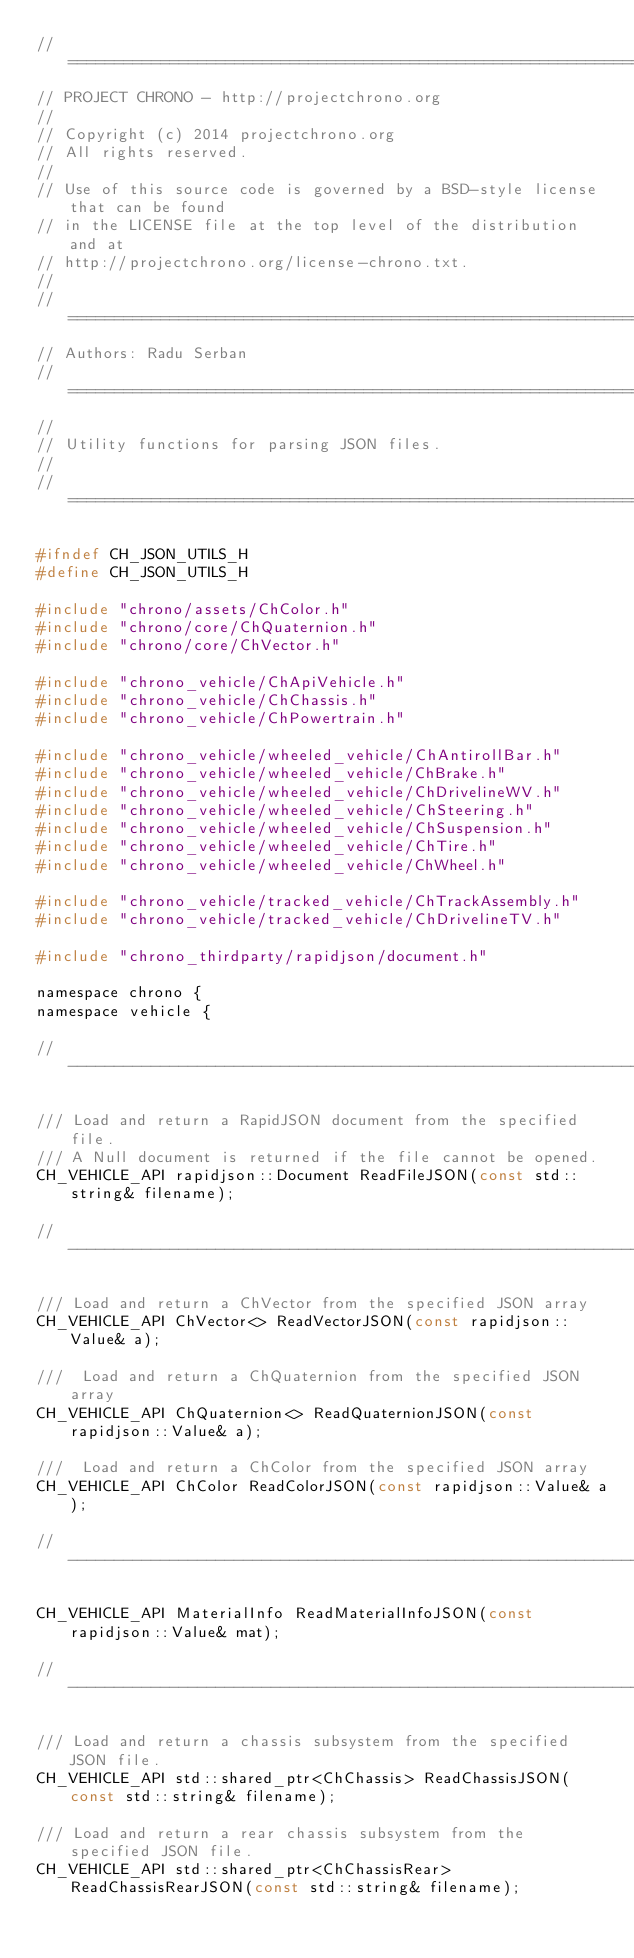<code> <loc_0><loc_0><loc_500><loc_500><_C_>// =============================================================================
// PROJECT CHRONO - http://projectchrono.org
//
// Copyright (c) 2014 projectchrono.org
// All rights reserved.
//
// Use of this source code is governed by a BSD-style license that can be found
// in the LICENSE file at the top level of the distribution and at
// http://projectchrono.org/license-chrono.txt.
//
// =============================================================================
// Authors: Radu Serban
// =============================================================================
//
// Utility functions for parsing JSON files.
//
// =============================================================================

#ifndef CH_JSON_UTILS_H
#define CH_JSON_UTILS_H

#include "chrono/assets/ChColor.h"
#include "chrono/core/ChQuaternion.h"
#include "chrono/core/ChVector.h"

#include "chrono_vehicle/ChApiVehicle.h"
#include "chrono_vehicle/ChChassis.h"
#include "chrono_vehicle/ChPowertrain.h"

#include "chrono_vehicle/wheeled_vehicle/ChAntirollBar.h"
#include "chrono_vehicle/wheeled_vehicle/ChBrake.h"
#include "chrono_vehicle/wheeled_vehicle/ChDrivelineWV.h"
#include "chrono_vehicle/wheeled_vehicle/ChSteering.h"
#include "chrono_vehicle/wheeled_vehicle/ChSuspension.h"
#include "chrono_vehicle/wheeled_vehicle/ChTire.h"
#include "chrono_vehicle/wheeled_vehicle/ChWheel.h"

#include "chrono_vehicle/tracked_vehicle/ChTrackAssembly.h"
#include "chrono_vehicle/tracked_vehicle/ChDrivelineTV.h"

#include "chrono_thirdparty/rapidjson/document.h"

namespace chrono {
namespace vehicle {

// -----------------------------------------------------------------------------

/// Load and return a RapidJSON document from the specified file.
/// A Null document is returned if the file cannot be opened.
CH_VEHICLE_API rapidjson::Document ReadFileJSON(const std::string& filename);

// -----------------------------------------------------------------------------

/// Load and return a ChVector from the specified JSON array
CH_VEHICLE_API ChVector<> ReadVectorJSON(const rapidjson::Value& a);

///  Load and return a ChQuaternion from the specified JSON array
CH_VEHICLE_API ChQuaternion<> ReadQuaternionJSON(const rapidjson::Value& a);

///  Load and return a ChColor from the specified JSON array
CH_VEHICLE_API ChColor ReadColorJSON(const rapidjson::Value& a);

// -----------------------------------------------------------------------------

CH_VEHICLE_API MaterialInfo ReadMaterialInfoJSON(const rapidjson::Value& mat);

// -----------------------------------------------------------------------------

/// Load and return a chassis subsystem from the specified JSON file.
CH_VEHICLE_API std::shared_ptr<ChChassis> ReadChassisJSON(const std::string& filename);

/// Load and return a rear chassis subsystem from the specified JSON file.
CH_VEHICLE_API std::shared_ptr<ChChassisRear> ReadChassisRearJSON(const std::string& filename);
</code> 